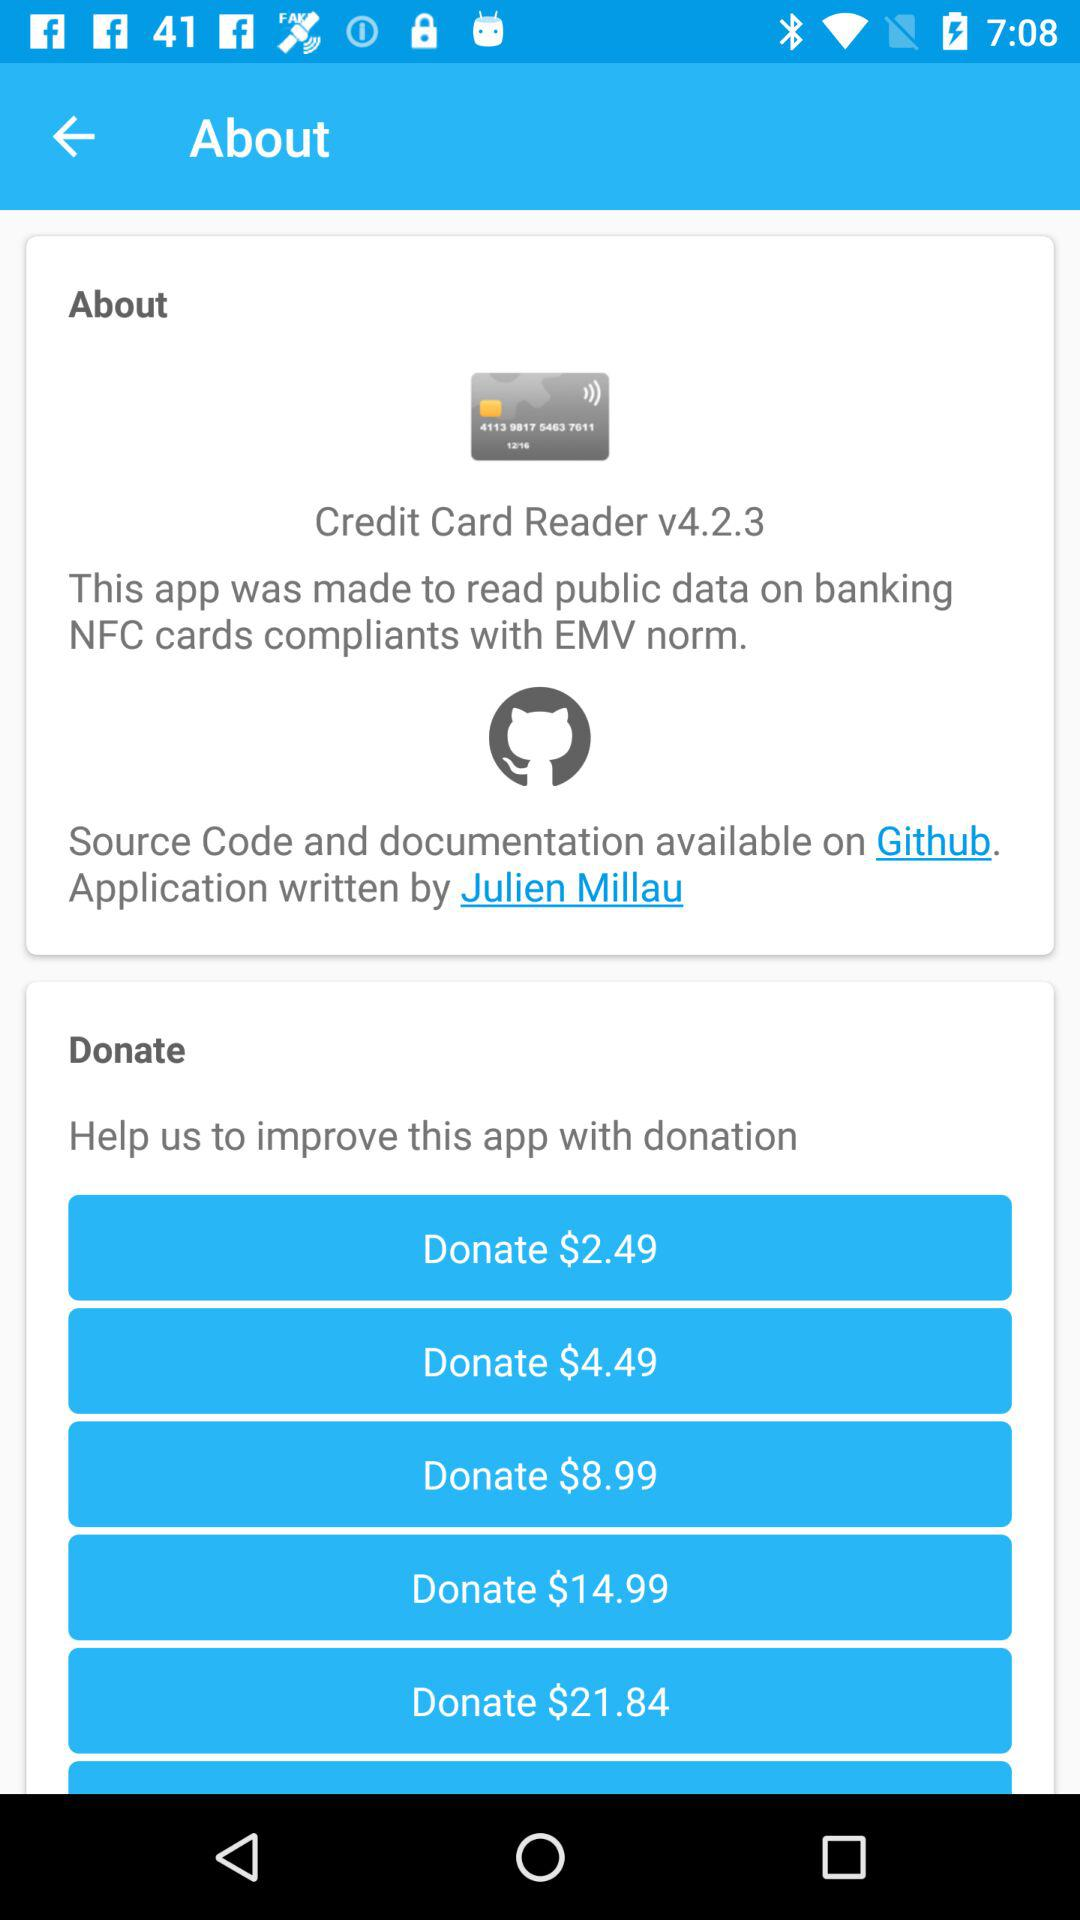What is the name of the application? The name of the application is "Credit Card Reader". 